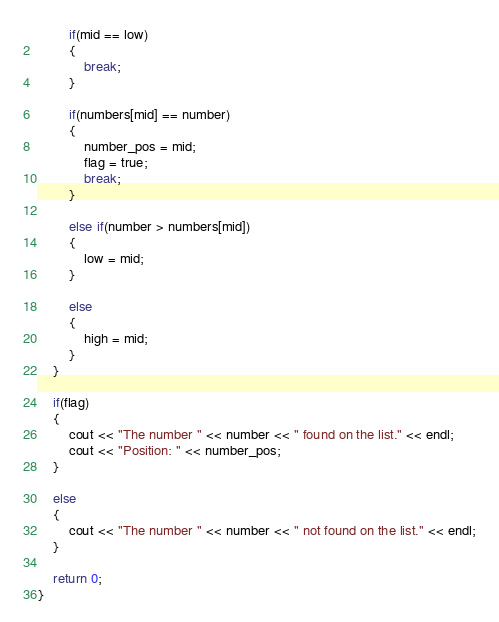<code> <loc_0><loc_0><loc_500><loc_500><_C++_>        if(mid == low)
        {
            break;
        }

        if(numbers[mid] == number)
        {
            number_pos = mid;
            flag = true;
            break;
        }

        else if(number > numbers[mid])
        {
            low = mid;
        }

        else
        {
            high = mid;
        }
    }

    if(flag)
    {
        cout << "The number " << number << " found on the list." << endl;
        cout << "Position: " << number_pos;
    }

    else
    {
        cout << "The number " << number << " not found on the list." << endl;
    }

    return 0;
}
</code> 